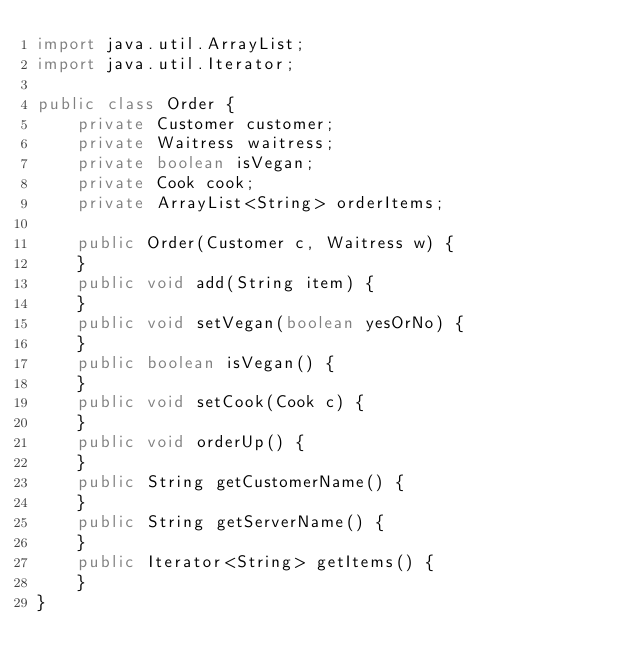Convert code to text. <code><loc_0><loc_0><loc_500><loc_500><_Java_>import java.util.ArrayList;
import java.util.Iterator;

public class Order {
    private Customer customer;
    private Waitress waitress;
    private boolean isVegan;
    private Cook cook;
    private ArrayList<String> orderItems;

    public Order(Customer c, Waitress w) {
    }
    public void add(String item) {
    }
    public void setVegan(boolean yesOrNo) {
    }
    public boolean isVegan() {
    }
    public void setCook(Cook c) {
    }
    public void orderUp() {
    }
    public String getCustomerName() {
    }
    public String getServerName() {
    }
    public Iterator<String> getItems() {
    }
}</code> 